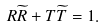<formula> <loc_0><loc_0><loc_500><loc_500>R \widetilde { R } + T \widetilde { T } = 1 .</formula> 